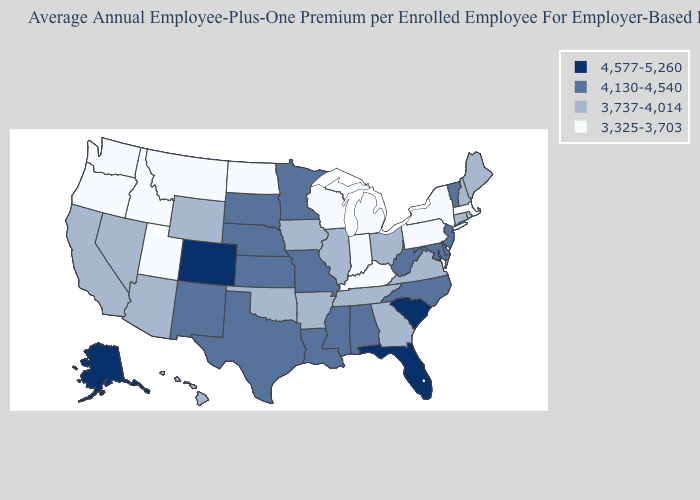Which states hav the highest value in the Northeast?
Quick response, please. New Jersey, Vermont. What is the lowest value in states that border Minnesota?
Be succinct. 3,325-3,703. What is the value of Virginia?
Give a very brief answer. 3,737-4,014. What is the highest value in states that border Colorado?
Be succinct. 4,130-4,540. Among the states that border Arizona , which have the highest value?
Short answer required. Colorado. Name the states that have a value in the range 4,130-4,540?
Quick response, please. Alabama, Delaware, Kansas, Louisiana, Maryland, Minnesota, Mississippi, Missouri, Nebraska, New Jersey, New Mexico, North Carolina, South Dakota, Texas, Vermont, West Virginia. What is the value of Texas?
Be succinct. 4,130-4,540. Name the states that have a value in the range 4,130-4,540?
Concise answer only. Alabama, Delaware, Kansas, Louisiana, Maryland, Minnesota, Mississippi, Missouri, Nebraska, New Jersey, New Mexico, North Carolina, South Dakota, Texas, Vermont, West Virginia. What is the value of Minnesota?
Give a very brief answer. 4,130-4,540. What is the lowest value in the USA?
Give a very brief answer. 3,325-3,703. What is the value of Maine?
Write a very short answer. 3,737-4,014. What is the value of Georgia?
Answer briefly. 3,737-4,014. Name the states that have a value in the range 4,130-4,540?
Concise answer only. Alabama, Delaware, Kansas, Louisiana, Maryland, Minnesota, Mississippi, Missouri, Nebraska, New Jersey, New Mexico, North Carolina, South Dakota, Texas, Vermont, West Virginia. What is the value of Colorado?
Short answer required. 4,577-5,260. Does the first symbol in the legend represent the smallest category?
Short answer required. No. 